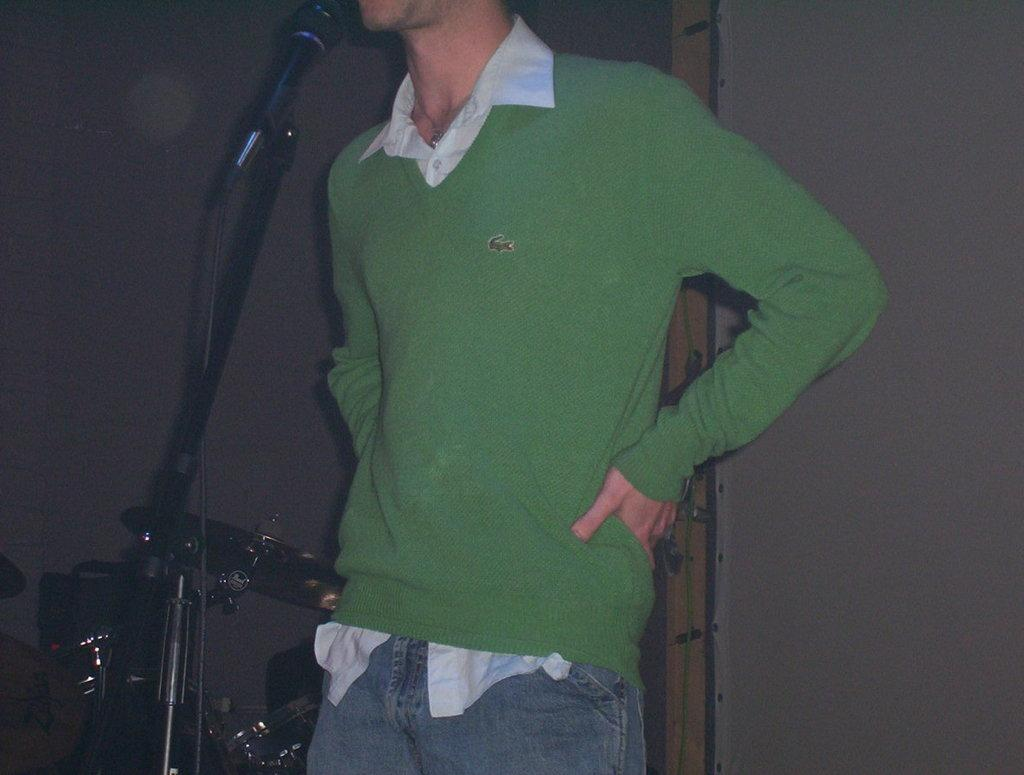What is the main subject of the image? There is a person in the image. What object is associated with the person in the image? There is a microphone in the image, which is attached to a stand. What other item can be seen in the image? There is a musical instrument in the image. How many cattle are present in the image? There are no cattle present in the image. What type of government is depicted in the image? There is no depiction of a government in the image. 